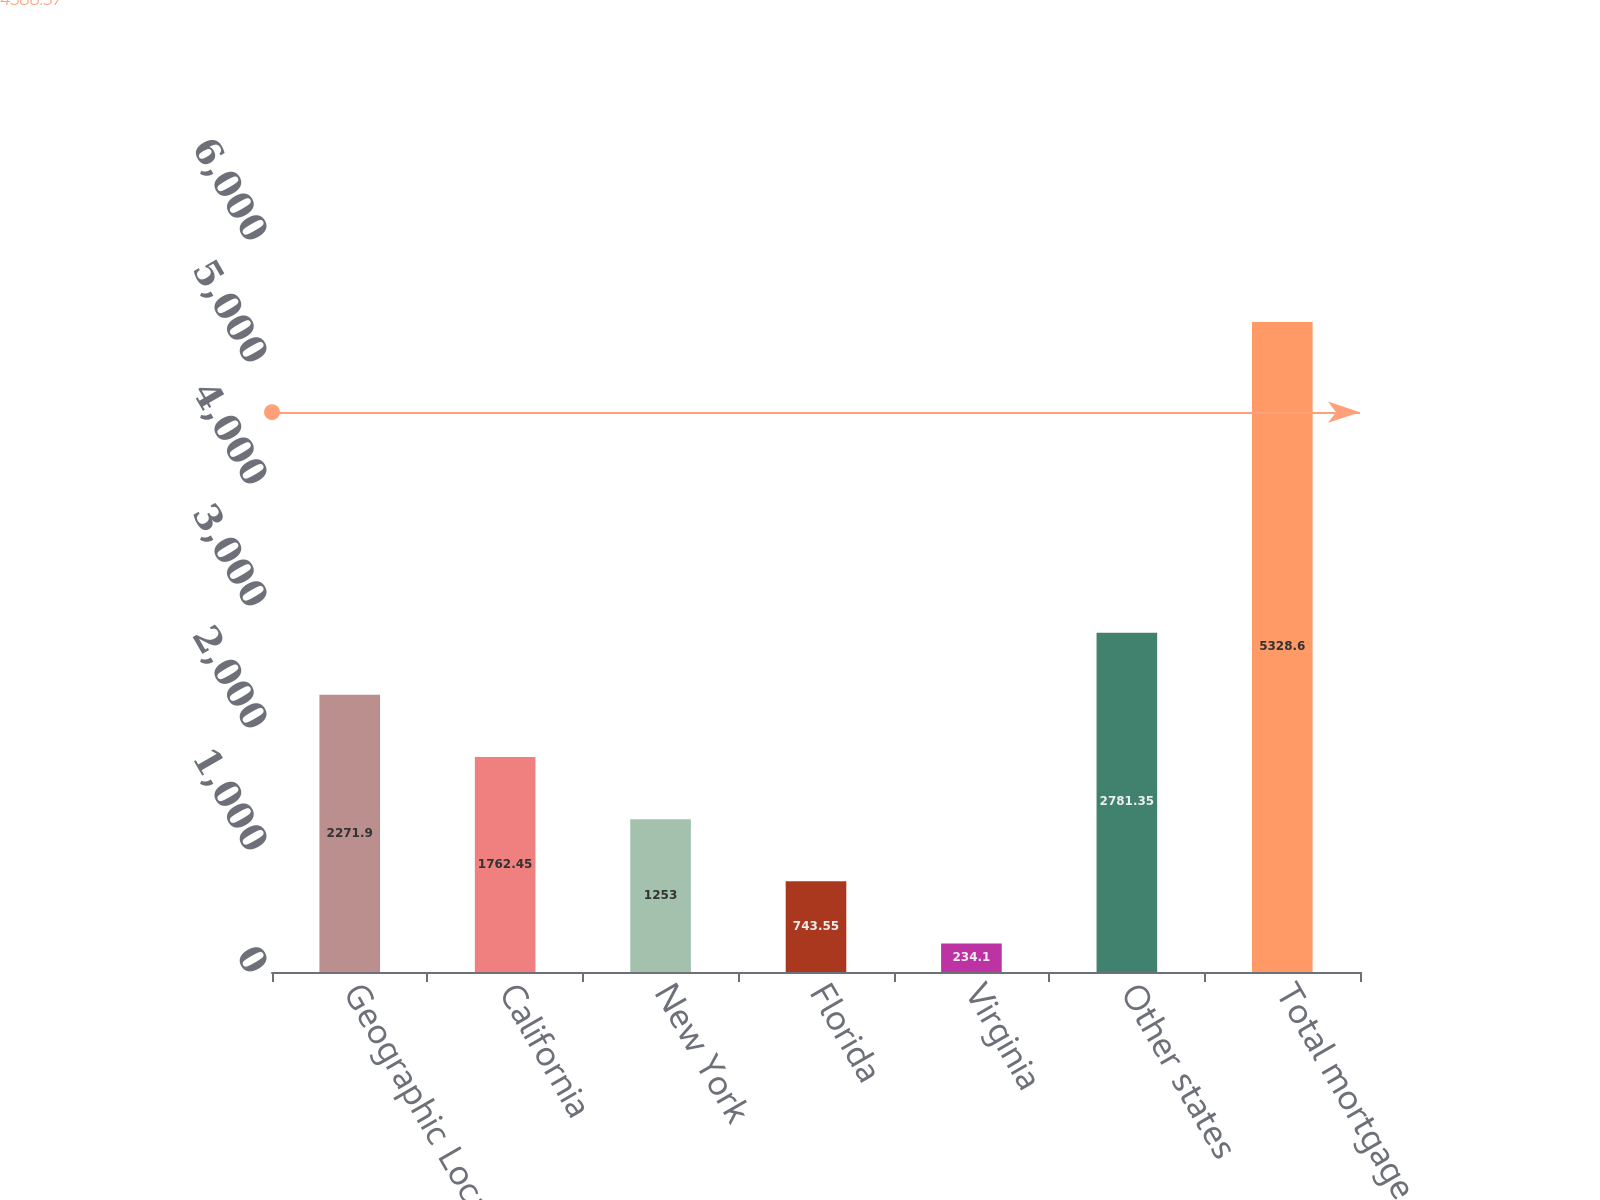Convert chart to OTSL. <chart><loc_0><loc_0><loc_500><loc_500><bar_chart><fcel>Geographic Location<fcel>California<fcel>New York<fcel>Florida<fcel>Virginia<fcel>Other states<fcel>Total mortgage loans<nl><fcel>2271.9<fcel>1762.45<fcel>1253<fcel>743.55<fcel>234.1<fcel>2781.35<fcel>5328.6<nl></chart> 